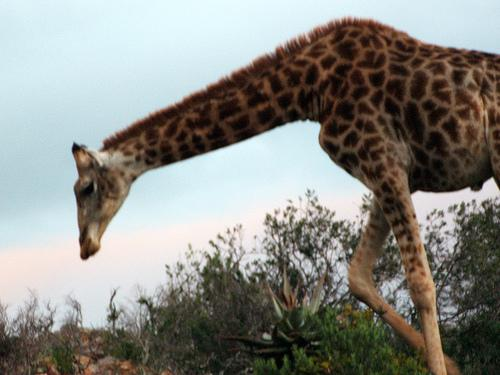Question: what animal is shown?
Choices:
A. Giraffe.
B. Cow.
C. Pig.
D. Cat.
Answer with the letter. Answer: A Question: what color is the sky?
Choices:
A. White.
B. Black.
C. Blue.
D. Pink.
Answer with the letter. Answer: C Question: where is this shot?
Choices:
A. Safari.
B. Zoo.
C. Park.
D. Highway.
Answer with the letter. Answer: A Question: how many giraffe are there?
Choices:
A. 2.
B. 3.
C. 4.
D. 1.
Answer with the letter. Answer: D 